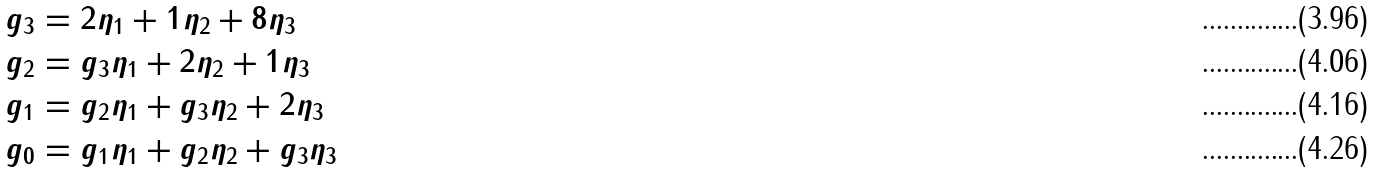Convert formula to latex. <formula><loc_0><loc_0><loc_500><loc_500>g _ { 3 } & = 2 \eta _ { 1 } + 1 \eta _ { 2 } + 8 \eta _ { 3 } \\ g _ { 2 } & = g _ { 3 } \eta _ { 1 } + 2 \eta _ { 2 } + 1 \eta _ { 3 } \\ g _ { 1 } & = g _ { 2 } \eta _ { 1 } + g _ { 3 } \eta _ { 2 } + 2 \eta _ { 3 } \\ g _ { 0 } & = g _ { 1 } \eta _ { 1 } + g _ { 2 } \eta _ { 2 } + g _ { 3 } \eta _ { 3 }</formula> 